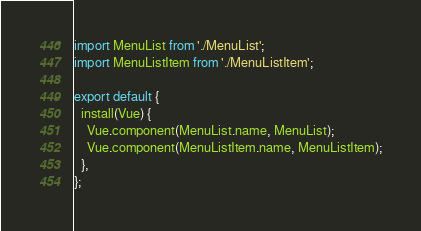<code> <loc_0><loc_0><loc_500><loc_500><_JavaScript_>import MenuList from './MenuList';
import MenuListItem from './MenuListItem';

export default {
  install(Vue) {
    Vue.component(MenuList.name, MenuList);
    Vue.component(MenuListItem.name, MenuListItem);
  },
};
</code> 